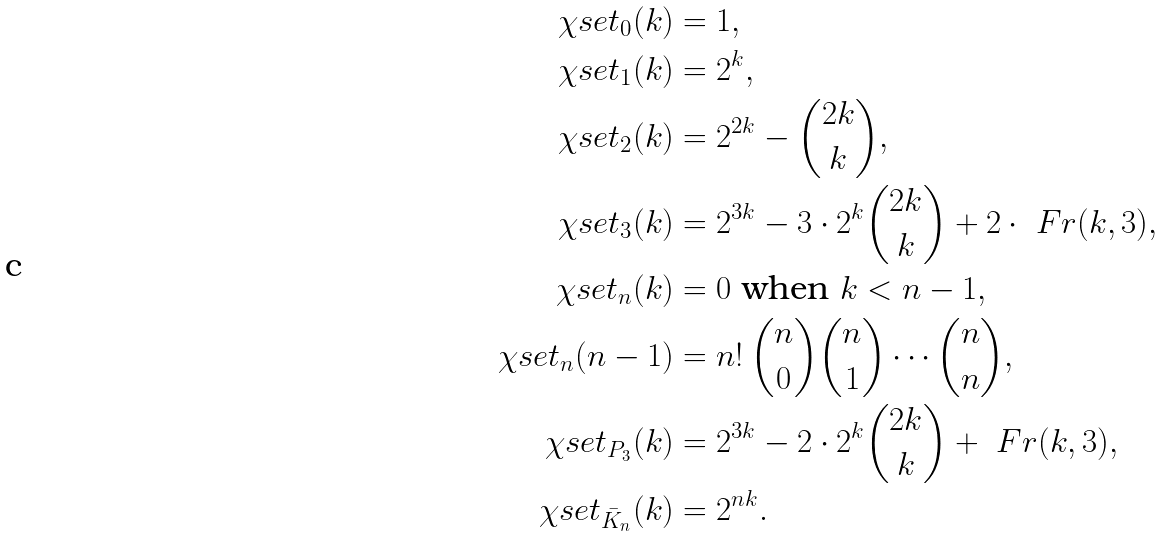<formula> <loc_0><loc_0><loc_500><loc_500>\chi s e t _ { 0 } ( k ) & = 1 , \\ \chi s e t _ { 1 } ( k ) & = 2 ^ { k } , \\ \chi s e t _ { 2 } ( k ) & = 2 ^ { 2 k } - \binom { 2 k } { k } , \\ \chi s e t _ { 3 } ( k ) & = 2 ^ { 3 k } - 3 \cdot 2 ^ { k } \binom { 2 k } { k } + 2 \cdot \ F r ( k , 3 ) , \\ \chi s e t _ { n } ( k ) & = 0 \text { when } k < n - 1 , \\ \chi s e t _ { n } ( n - 1 ) & = n ! \, \binom { n } { 0 } \binom { n } { 1 } \cdots \binom { n } { n } , \\ \chi s e t _ { P _ { 3 } } ( k ) & = 2 ^ { 3 k } - 2 \cdot 2 ^ { k } \binom { 2 k } { k } + \ F r ( k , 3 ) , \\ \chi s e t _ { \bar { K } _ { n } } ( k ) & = 2 ^ { n k } .</formula> 